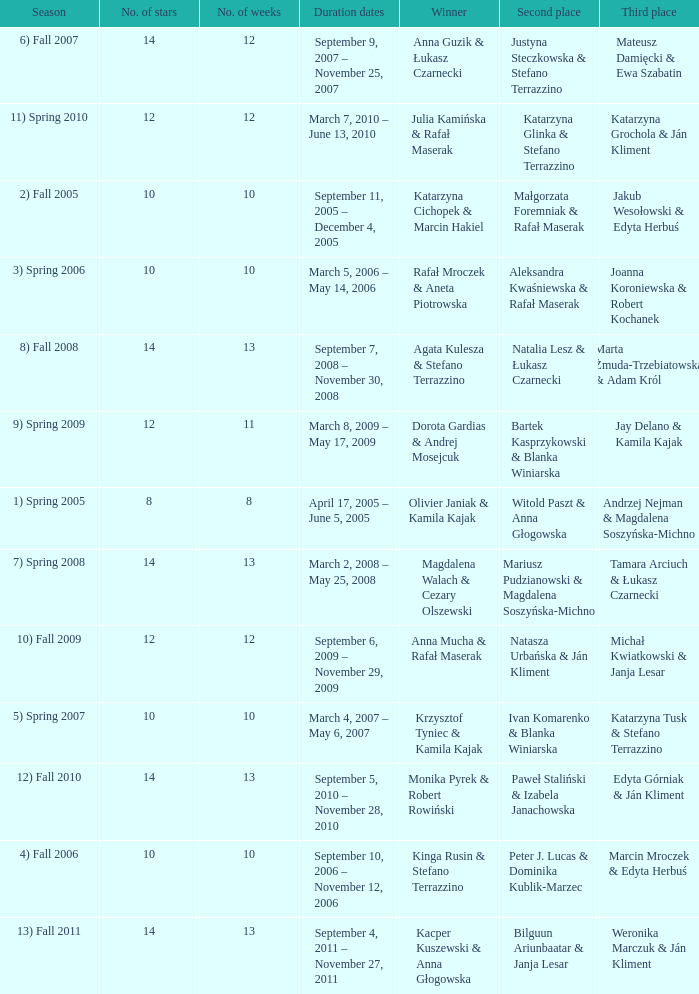Who got second place when the winners were rafał mroczek & aneta piotrowska? Aleksandra Kwaśniewska & Rafał Maserak. 